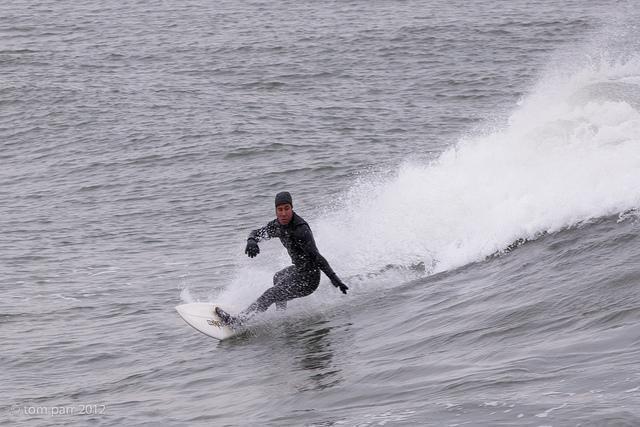How many cake clouds are there?
Give a very brief answer. 0. 